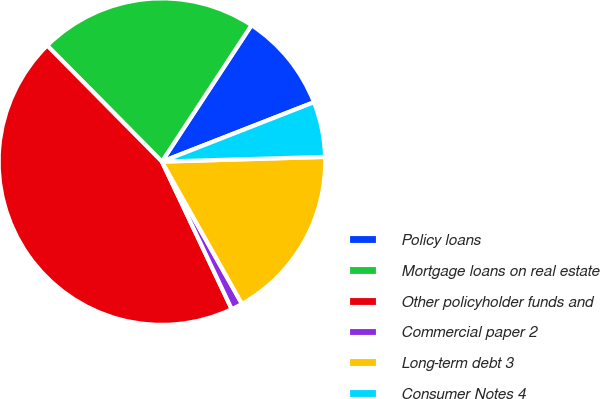<chart> <loc_0><loc_0><loc_500><loc_500><pie_chart><fcel>Policy loans<fcel>Mortgage loans on real estate<fcel>Other policyholder funds and<fcel>Commercial paper 2<fcel>Long-term debt 3<fcel>Consumer Notes 4<nl><fcel>9.82%<fcel>21.65%<fcel>44.62%<fcel>1.12%<fcel>17.3%<fcel>5.47%<nl></chart> 